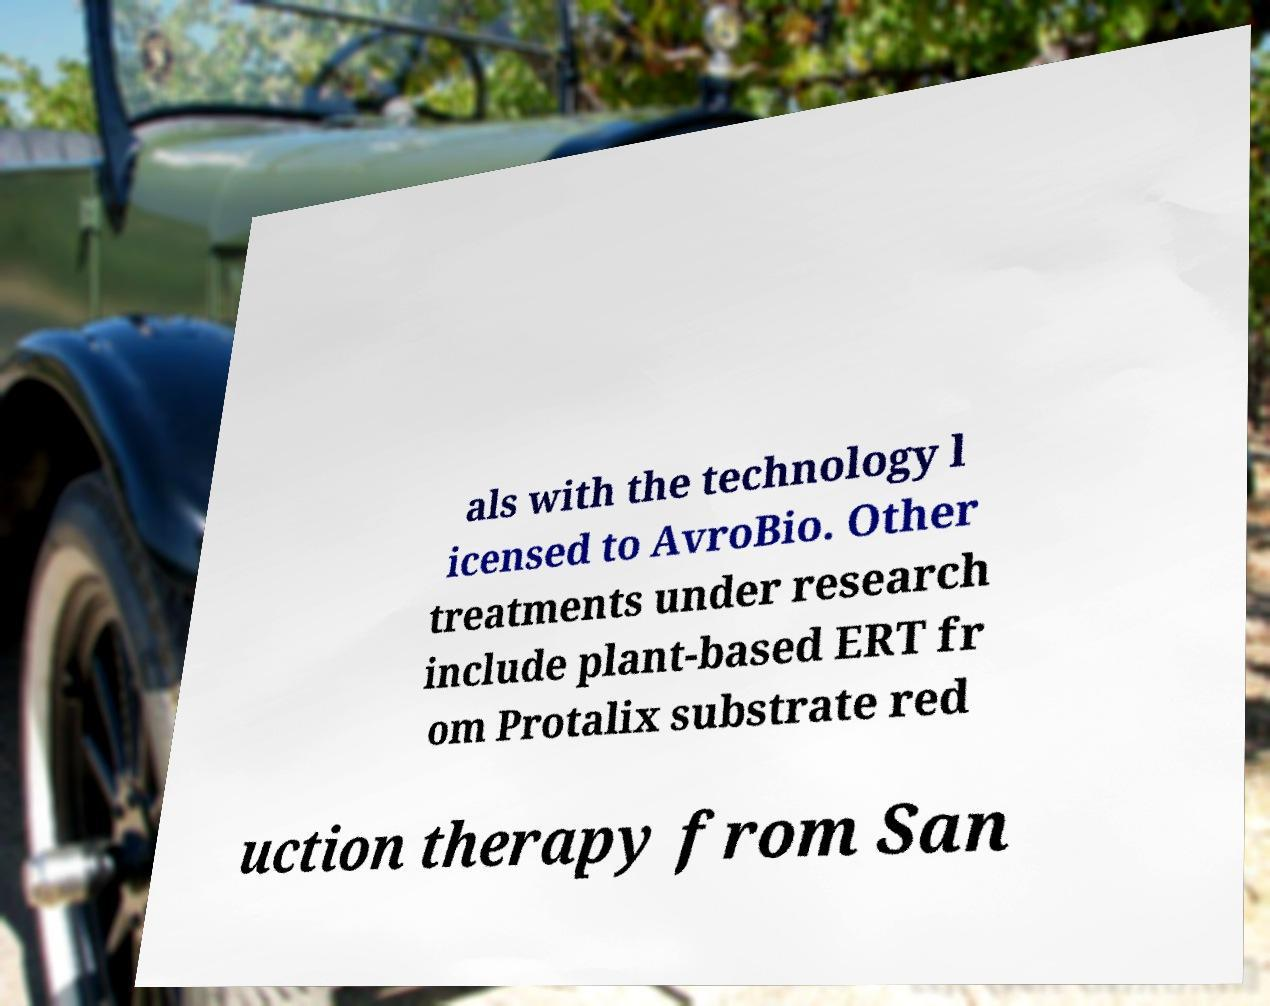For documentation purposes, I need the text within this image transcribed. Could you provide that? als with the technology l icensed to AvroBio. Other treatments under research include plant-based ERT fr om Protalix substrate red uction therapy from San 